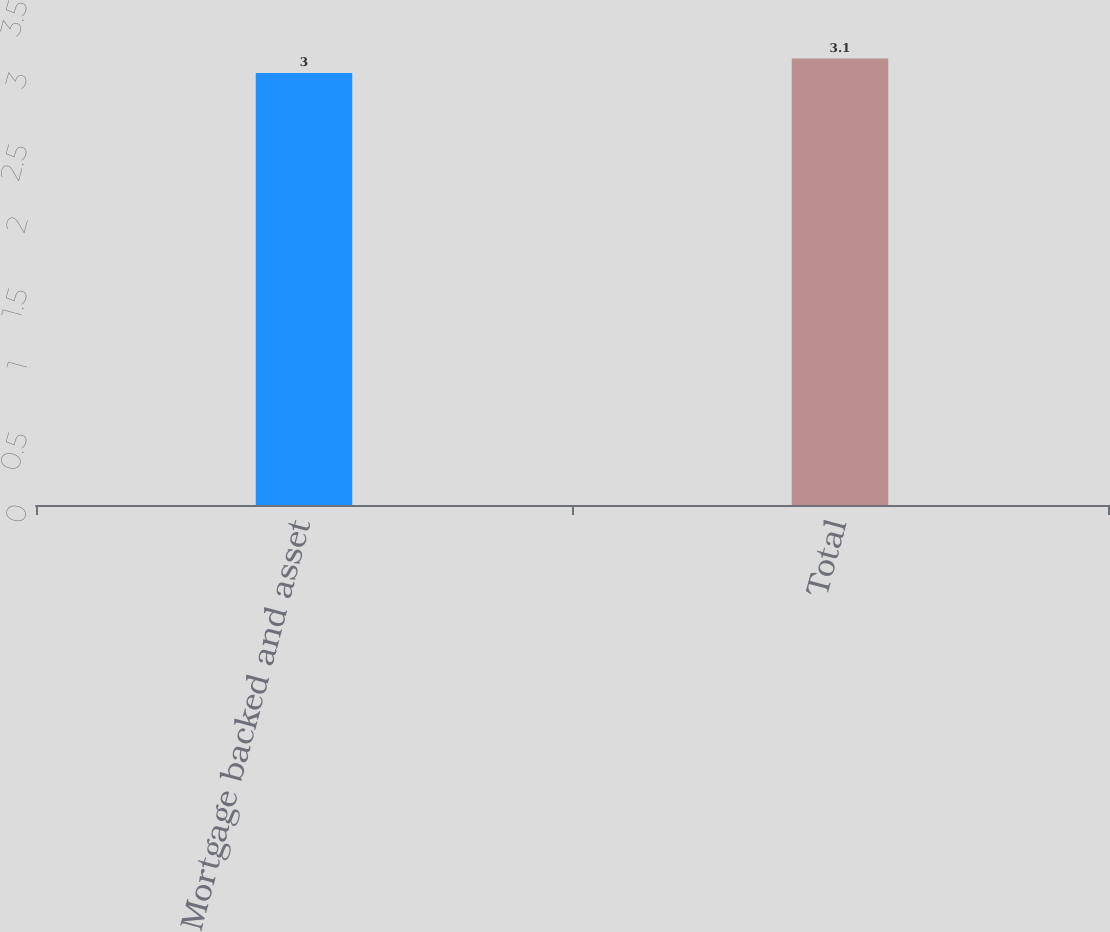Convert chart to OTSL. <chart><loc_0><loc_0><loc_500><loc_500><bar_chart><fcel>Mortgage backed and asset<fcel>Total<nl><fcel>3<fcel>3.1<nl></chart> 